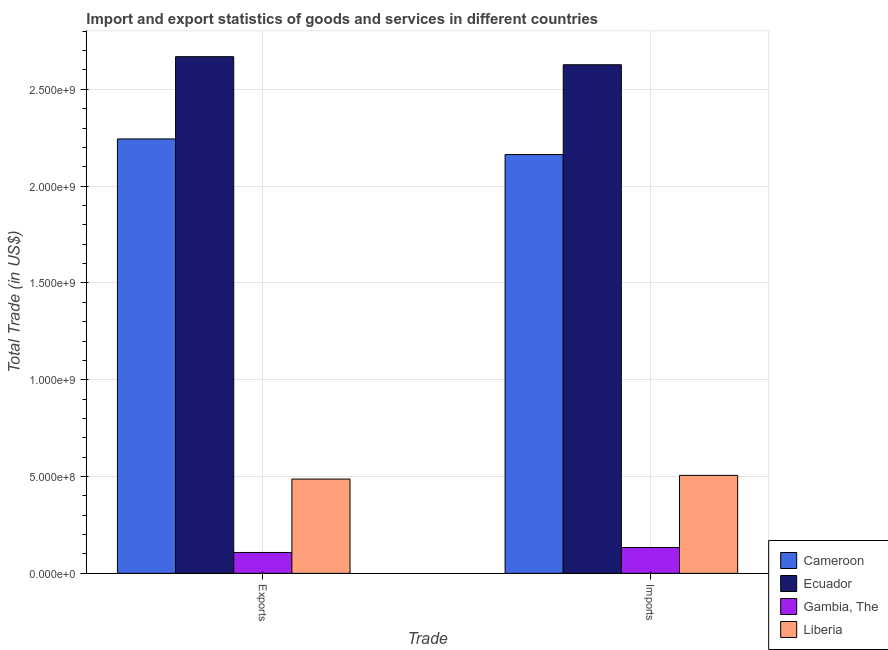How many different coloured bars are there?
Keep it short and to the point. 4. How many groups of bars are there?
Your response must be concise. 2. Are the number of bars per tick equal to the number of legend labels?
Ensure brevity in your answer.  Yes. What is the label of the 2nd group of bars from the left?
Offer a very short reply. Imports. What is the imports of goods and services in Cameroon?
Your answer should be very brief. 2.16e+09. Across all countries, what is the maximum export of goods and services?
Your response must be concise. 2.67e+09. Across all countries, what is the minimum export of goods and services?
Provide a short and direct response. 1.08e+08. In which country was the export of goods and services maximum?
Your answer should be compact. Ecuador. In which country was the imports of goods and services minimum?
Your answer should be very brief. Gambia, The. What is the total imports of goods and services in the graph?
Offer a terse response. 5.43e+09. What is the difference between the export of goods and services in Ecuador and that in Gambia, The?
Give a very brief answer. 2.56e+09. What is the difference between the imports of goods and services in Ecuador and the export of goods and services in Cameroon?
Keep it short and to the point. 3.83e+08. What is the average export of goods and services per country?
Keep it short and to the point. 1.38e+09. What is the difference between the imports of goods and services and export of goods and services in Liberia?
Offer a terse response. 1.90e+07. In how many countries, is the export of goods and services greater than 800000000 US$?
Your response must be concise. 2. What is the ratio of the export of goods and services in Gambia, The to that in Liberia?
Your response must be concise. 0.22. In how many countries, is the imports of goods and services greater than the average imports of goods and services taken over all countries?
Offer a terse response. 2. What does the 2nd bar from the left in Exports represents?
Make the answer very short. Ecuador. What does the 4th bar from the right in Exports represents?
Offer a very short reply. Cameroon. Are all the bars in the graph horizontal?
Offer a terse response. No. What is the difference between two consecutive major ticks on the Y-axis?
Offer a terse response. 5.00e+08. Does the graph contain any zero values?
Make the answer very short. No. Where does the legend appear in the graph?
Give a very brief answer. Bottom right. How many legend labels are there?
Keep it short and to the point. 4. How are the legend labels stacked?
Keep it short and to the point. Vertical. What is the title of the graph?
Ensure brevity in your answer.  Import and export statistics of goods and services in different countries. Does "Aruba" appear as one of the legend labels in the graph?
Offer a terse response. No. What is the label or title of the X-axis?
Provide a short and direct response. Trade. What is the label or title of the Y-axis?
Offer a very short reply. Total Trade (in US$). What is the Total Trade (in US$) in Cameroon in Exports?
Provide a short and direct response. 2.24e+09. What is the Total Trade (in US$) of Ecuador in Exports?
Give a very brief answer. 2.67e+09. What is the Total Trade (in US$) in Gambia, The in Exports?
Provide a short and direct response. 1.08e+08. What is the Total Trade (in US$) of Liberia in Exports?
Provide a short and direct response. 4.87e+08. What is the Total Trade (in US$) in Cameroon in Imports?
Your answer should be compact. 2.16e+09. What is the Total Trade (in US$) in Ecuador in Imports?
Your answer should be compact. 2.63e+09. What is the Total Trade (in US$) in Gambia, The in Imports?
Provide a short and direct response. 1.33e+08. What is the Total Trade (in US$) of Liberia in Imports?
Offer a terse response. 5.06e+08. Across all Trade, what is the maximum Total Trade (in US$) in Cameroon?
Your answer should be very brief. 2.24e+09. Across all Trade, what is the maximum Total Trade (in US$) of Ecuador?
Offer a very short reply. 2.67e+09. Across all Trade, what is the maximum Total Trade (in US$) of Gambia, The?
Offer a very short reply. 1.33e+08. Across all Trade, what is the maximum Total Trade (in US$) of Liberia?
Offer a terse response. 5.06e+08. Across all Trade, what is the minimum Total Trade (in US$) of Cameroon?
Provide a succinct answer. 2.16e+09. Across all Trade, what is the minimum Total Trade (in US$) of Ecuador?
Your answer should be compact. 2.63e+09. Across all Trade, what is the minimum Total Trade (in US$) of Gambia, The?
Ensure brevity in your answer.  1.08e+08. Across all Trade, what is the minimum Total Trade (in US$) in Liberia?
Your response must be concise. 4.87e+08. What is the total Total Trade (in US$) in Cameroon in the graph?
Your answer should be compact. 4.41e+09. What is the total Total Trade (in US$) in Ecuador in the graph?
Offer a terse response. 5.30e+09. What is the total Total Trade (in US$) of Gambia, The in the graph?
Give a very brief answer. 2.41e+08. What is the total Total Trade (in US$) in Liberia in the graph?
Offer a very short reply. 9.93e+08. What is the difference between the Total Trade (in US$) of Cameroon in Exports and that in Imports?
Give a very brief answer. 8.08e+07. What is the difference between the Total Trade (in US$) in Ecuador in Exports and that in Imports?
Keep it short and to the point. 4.17e+07. What is the difference between the Total Trade (in US$) in Gambia, The in Exports and that in Imports?
Provide a succinct answer. -2.56e+07. What is the difference between the Total Trade (in US$) of Liberia in Exports and that in Imports?
Offer a terse response. -1.90e+07. What is the difference between the Total Trade (in US$) of Cameroon in Exports and the Total Trade (in US$) of Ecuador in Imports?
Your answer should be compact. -3.83e+08. What is the difference between the Total Trade (in US$) of Cameroon in Exports and the Total Trade (in US$) of Gambia, The in Imports?
Make the answer very short. 2.11e+09. What is the difference between the Total Trade (in US$) of Cameroon in Exports and the Total Trade (in US$) of Liberia in Imports?
Ensure brevity in your answer.  1.74e+09. What is the difference between the Total Trade (in US$) of Ecuador in Exports and the Total Trade (in US$) of Gambia, The in Imports?
Ensure brevity in your answer.  2.54e+09. What is the difference between the Total Trade (in US$) of Ecuador in Exports and the Total Trade (in US$) of Liberia in Imports?
Make the answer very short. 2.16e+09. What is the difference between the Total Trade (in US$) of Gambia, The in Exports and the Total Trade (in US$) of Liberia in Imports?
Give a very brief answer. -3.98e+08. What is the average Total Trade (in US$) in Cameroon per Trade?
Keep it short and to the point. 2.20e+09. What is the average Total Trade (in US$) in Ecuador per Trade?
Ensure brevity in your answer.  2.65e+09. What is the average Total Trade (in US$) in Gambia, The per Trade?
Offer a terse response. 1.21e+08. What is the average Total Trade (in US$) in Liberia per Trade?
Offer a terse response. 4.97e+08. What is the difference between the Total Trade (in US$) of Cameroon and Total Trade (in US$) of Ecuador in Exports?
Your response must be concise. -4.25e+08. What is the difference between the Total Trade (in US$) in Cameroon and Total Trade (in US$) in Gambia, The in Exports?
Offer a terse response. 2.14e+09. What is the difference between the Total Trade (in US$) in Cameroon and Total Trade (in US$) in Liberia in Exports?
Your answer should be compact. 1.76e+09. What is the difference between the Total Trade (in US$) in Ecuador and Total Trade (in US$) in Gambia, The in Exports?
Your answer should be compact. 2.56e+09. What is the difference between the Total Trade (in US$) in Ecuador and Total Trade (in US$) in Liberia in Exports?
Provide a succinct answer. 2.18e+09. What is the difference between the Total Trade (in US$) of Gambia, The and Total Trade (in US$) of Liberia in Exports?
Keep it short and to the point. -3.79e+08. What is the difference between the Total Trade (in US$) in Cameroon and Total Trade (in US$) in Ecuador in Imports?
Your response must be concise. -4.64e+08. What is the difference between the Total Trade (in US$) in Cameroon and Total Trade (in US$) in Gambia, The in Imports?
Offer a very short reply. 2.03e+09. What is the difference between the Total Trade (in US$) in Cameroon and Total Trade (in US$) in Liberia in Imports?
Give a very brief answer. 1.66e+09. What is the difference between the Total Trade (in US$) in Ecuador and Total Trade (in US$) in Gambia, The in Imports?
Make the answer very short. 2.49e+09. What is the difference between the Total Trade (in US$) of Ecuador and Total Trade (in US$) of Liberia in Imports?
Keep it short and to the point. 2.12e+09. What is the difference between the Total Trade (in US$) in Gambia, The and Total Trade (in US$) in Liberia in Imports?
Provide a short and direct response. -3.73e+08. What is the ratio of the Total Trade (in US$) of Cameroon in Exports to that in Imports?
Keep it short and to the point. 1.04. What is the ratio of the Total Trade (in US$) in Ecuador in Exports to that in Imports?
Keep it short and to the point. 1.02. What is the ratio of the Total Trade (in US$) in Gambia, The in Exports to that in Imports?
Ensure brevity in your answer.  0.81. What is the ratio of the Total Trade (in US$) of Liberia in Exports to that in Imports?
Offer a very short reply. 0.96. What is the difference between the highest and the second highest Total Trade (in US$) of Cameroon?
Provide a short and direct response. 8.08e+07. What is the difference between the highest and the second highest Total Trade (in US$) in Ecuador?
Your answer should be very brief. 4.17e+07. What is the difference between the highest and the second highest Total Trade (in US$) in Gambia, The?
Your response must be concise. 2.56e+07. What is the difference between the highest and the second highest Total Trade (in US$) of Liberia?
Ensure brevity in your answer.  1.90e+07. What is the difference between the highest and the lowest Total Trade (in US$) of Cameroon?
Your answer should be compact. 8.08e+07. What is the difference between the highest and the lowest Total Trade (in US$) of Ecuador?
Give a very brief answer. 4.17e+07. What is the difference between the highest and the lowest Total Trade (in US$) in Gambia, The?
Offer a very short reply. 2.56e+07. What is the difference between the highest and the lowest Total Trade (in US$) of Liberia?
Your response must be concise. 1.90e+07. 